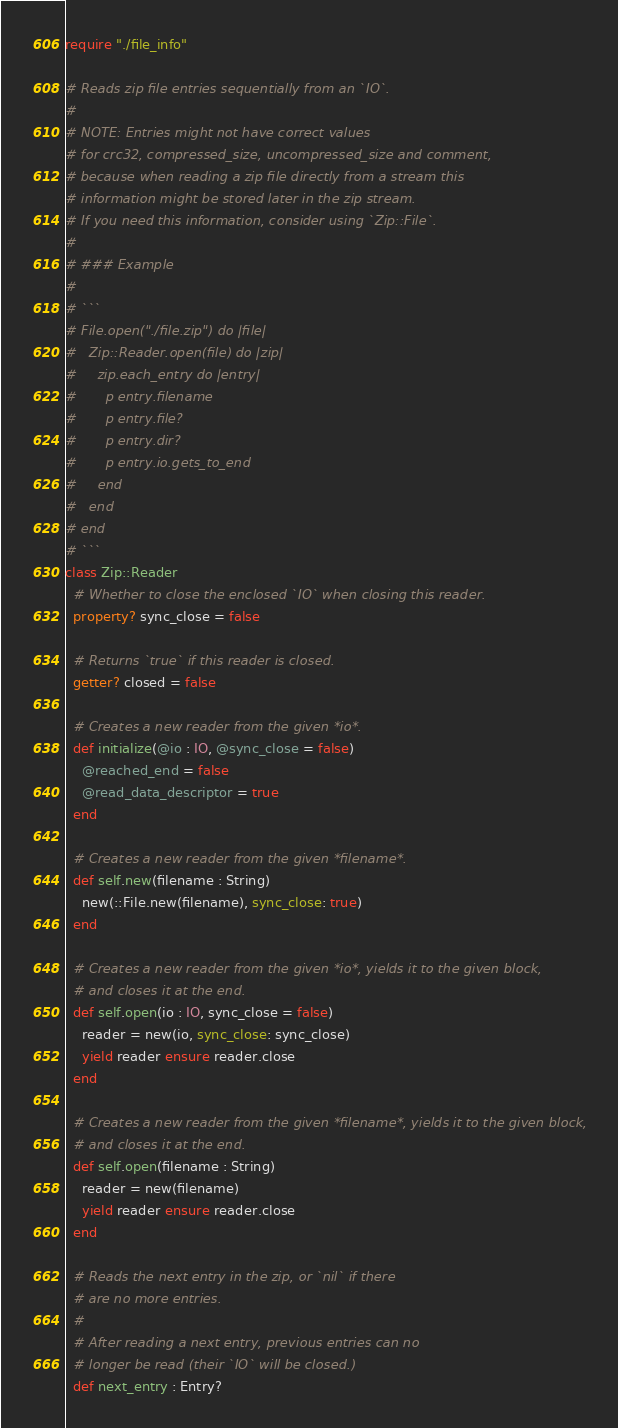Convert code to text. <code><loc_0><loc_0><loc_500><loc_500><_Crystal_>require "./file_info"

# Reads zip file entries sequentially from an `IO`.
#
# NOTE: Entries might not have correct values
# for crc32, compressed_size, uncompressed_size and comment,
# because when reading a zip file directly from a stream this
# information might be stored later in the zip stream.
# If you need this information, consider using `Zip::File`.
#
# ### Example
#
# ```
# File.open("./file.zip") do |file|
#   Zip::Reader.open(file) do |zip|
#     zip.each_entry do |entry|
#       p entry.filename
#       p entry.file?
#       p entry.dir?
#       p entry.io.gets_to_end
#     end
#   end
# end
# ```
class Zip::Reader
  # Whether to close the enclosed `IO` when closing this reader.
  property? sync_close = false

  # Returns `true` if this reader is closed.
  getter? closed = false

  # Creates a new reader from the given *io*.
  def initialize(@io : IO, @sync_close = false)
    @reached_end = false
    @read_data_descriptor = true
  end

  # Creates a new reader from the given *filename*.
  def self.new(filename : String)
    new(::File.new(filename), sync_close: true)
  end

  # Creates a new reader from the given *io*, yields it to the given block,
  # and closes it at the end.
  def self.open(io : IO, sync_close = false)
    reader = new(io, sync_close: sync_close)
    yield reader ensure reader.close
  end

  # Creates a new reader from the given *filename*, yields it to the given block,
  # and closes it at the end.
  def self.open(filename : String)
    reader = new(filename)
    yield reader ensure reader.close
  end

  # Reads the next entry in the zip, or `nil` if there
  # are no more entries.
  #
  # After reading a next entry, previous entries can no
  # longer be read (their `IO` will be closed.)
  def next_entry : Entry?</code> 